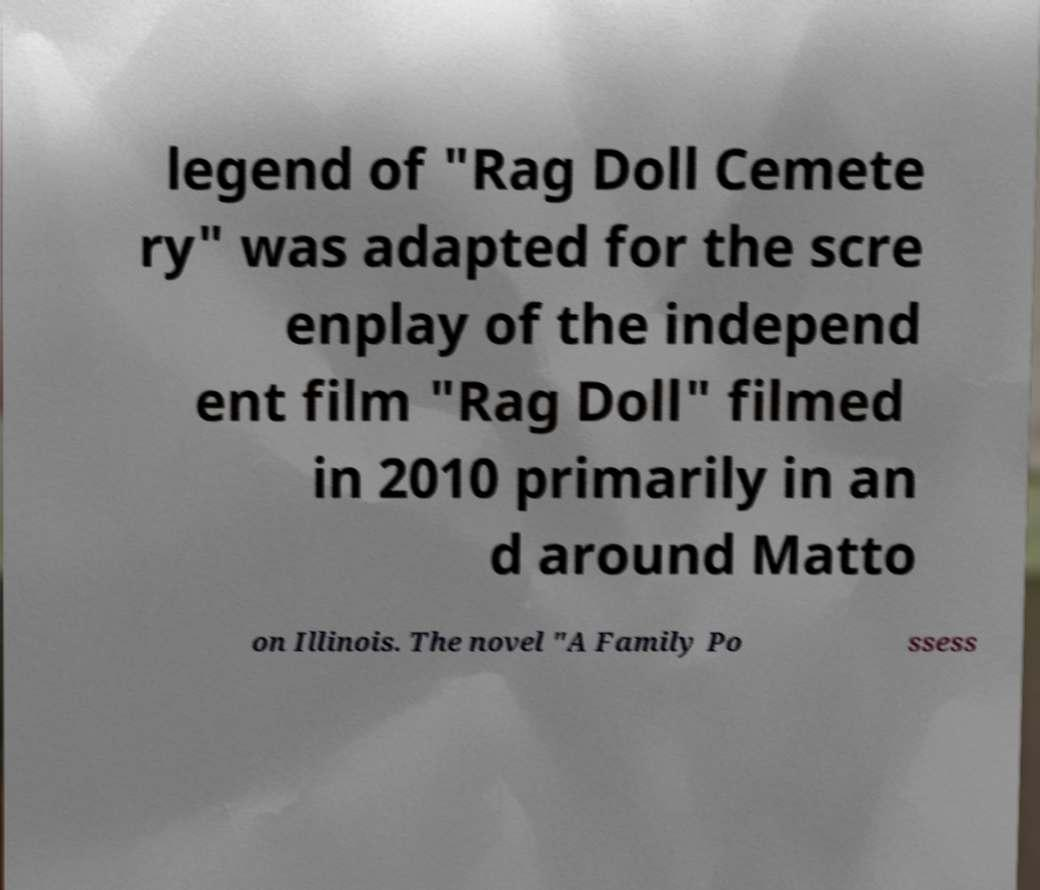What messages or text are displayed in this image? I need them in a readable, typed format. legend of "Rag Doll Cemete ry" was adapted for the scre enplay of the independ ent film "Rag Doll" filmed in 2010 primarily in an d around Matto on Illinois. The novel "A Family Po ssess 